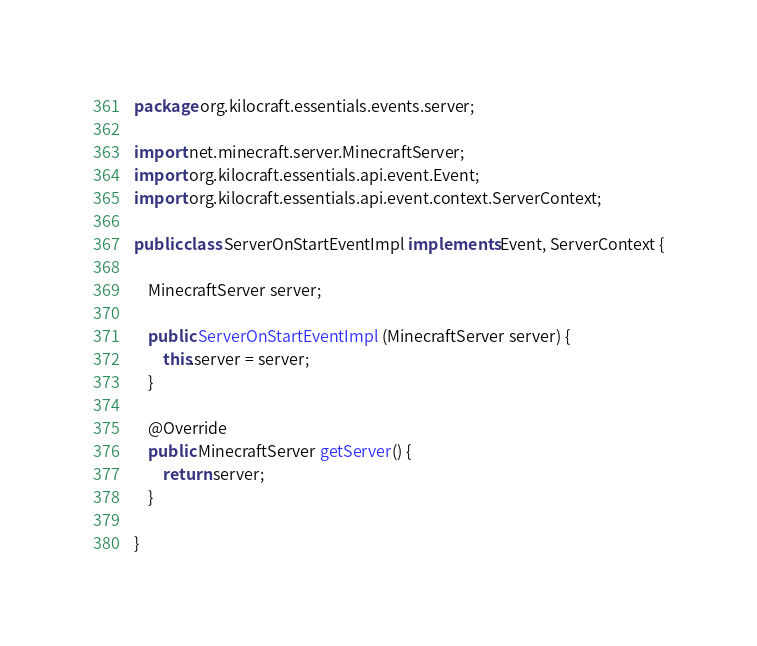<code> <loc_0><loc_0><loc_500><loc_500><_Java_>package org.kilocraft.essentials.events.server;

import net.minecraft.server.MinecraftServer;
import org.kilocraft.essentials.api.event.Event;
import org.kilocraft.essentials.api.event.context.ServerContext;

public class ServerOnStartEventImpl implements Event, ServerContext {

	MinecraftServer server;
	
	public ServerOnStartEventImpl (MinecraftServer server) {
		this.server = server;
	}
	
	@Override
	public MinecraftServer getServer() {
		return server;
	}

}
</code> 